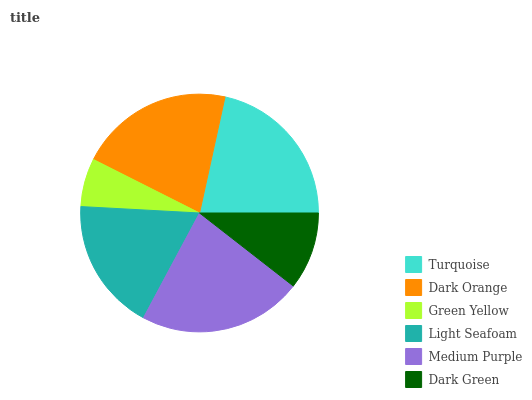Is Green Yellow the minimum?
Answer yes or no. Yes. Is Medium Purple the maximum?
Answer yes or no. Yes. Is Dark Orange the minimum?
Answer yes or no. No. Is Dark Orange the maximum?
Answer yes or no. No. Is Turquoise greater than Dark Orange?
Answer yes or no. Yes. Is Dark Orange less than Turquoise?
Answer yes or no. Yes. Is Dark Orange greater than Turquoise?
Answer yes or no. No. Is Turquoise less than Dark Orange?
Answer yes or no. No. Is Dark Orange the high median?
Answer yes or no. Yes. Is Light Seafoam the low median?
Answer yes or no. Yes. Is Dark Green the high median?
Answer yes or no. No. Is Dark Orange the low median?
Answer yes or no. No. 